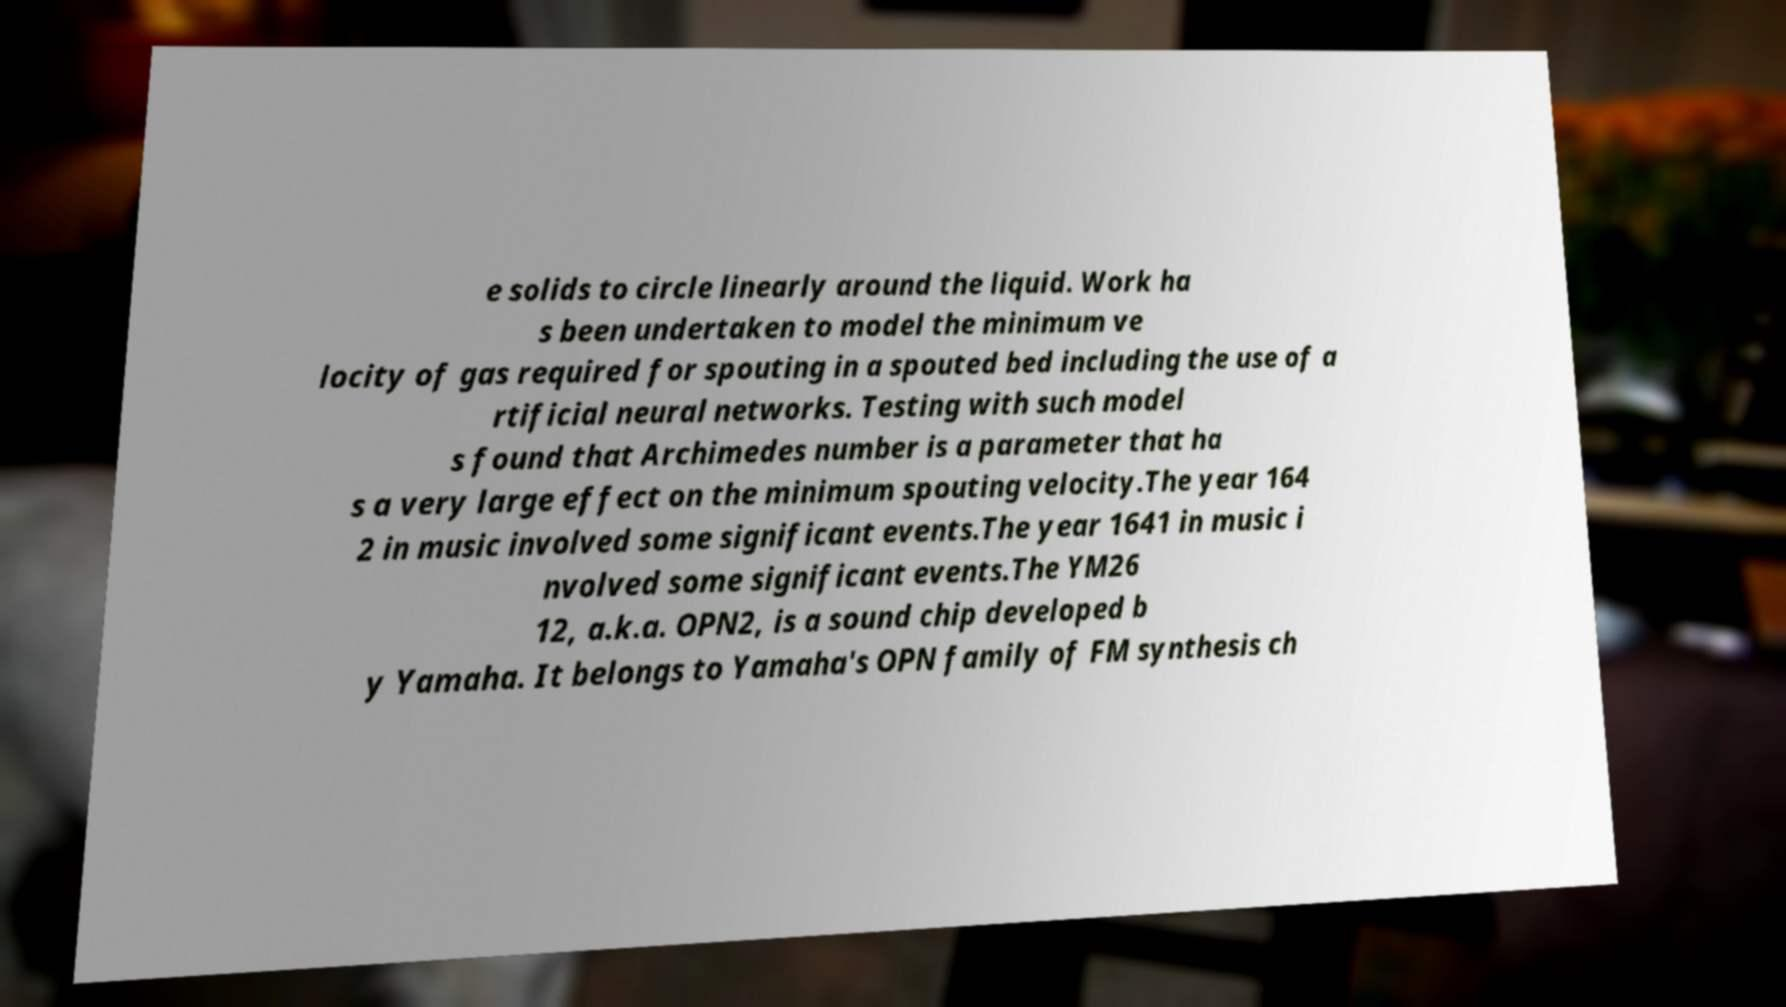Can you read and provide the text displayed in the image?This photo seems to have some interesting text. Can you extract and type it out for me? e solids to circle linearly around the liquid. Work ha s been undertaken to model the minimum ve locity of gas required for spouting in a spouted bed including the use of a rtificial neural networks. Testing with such model s found that Archimedes number is a parameter that ha s a very large effect on the minimum spouting velocity.The year 164 2 in music involved some significant events.The year 1641 in music i nvolved some significant events.The YM26 12, a.k.a. OPN2, is a sound chip developed b y Yamaha. It belongs to Yamaha's OPN family of FM synthesis ch 